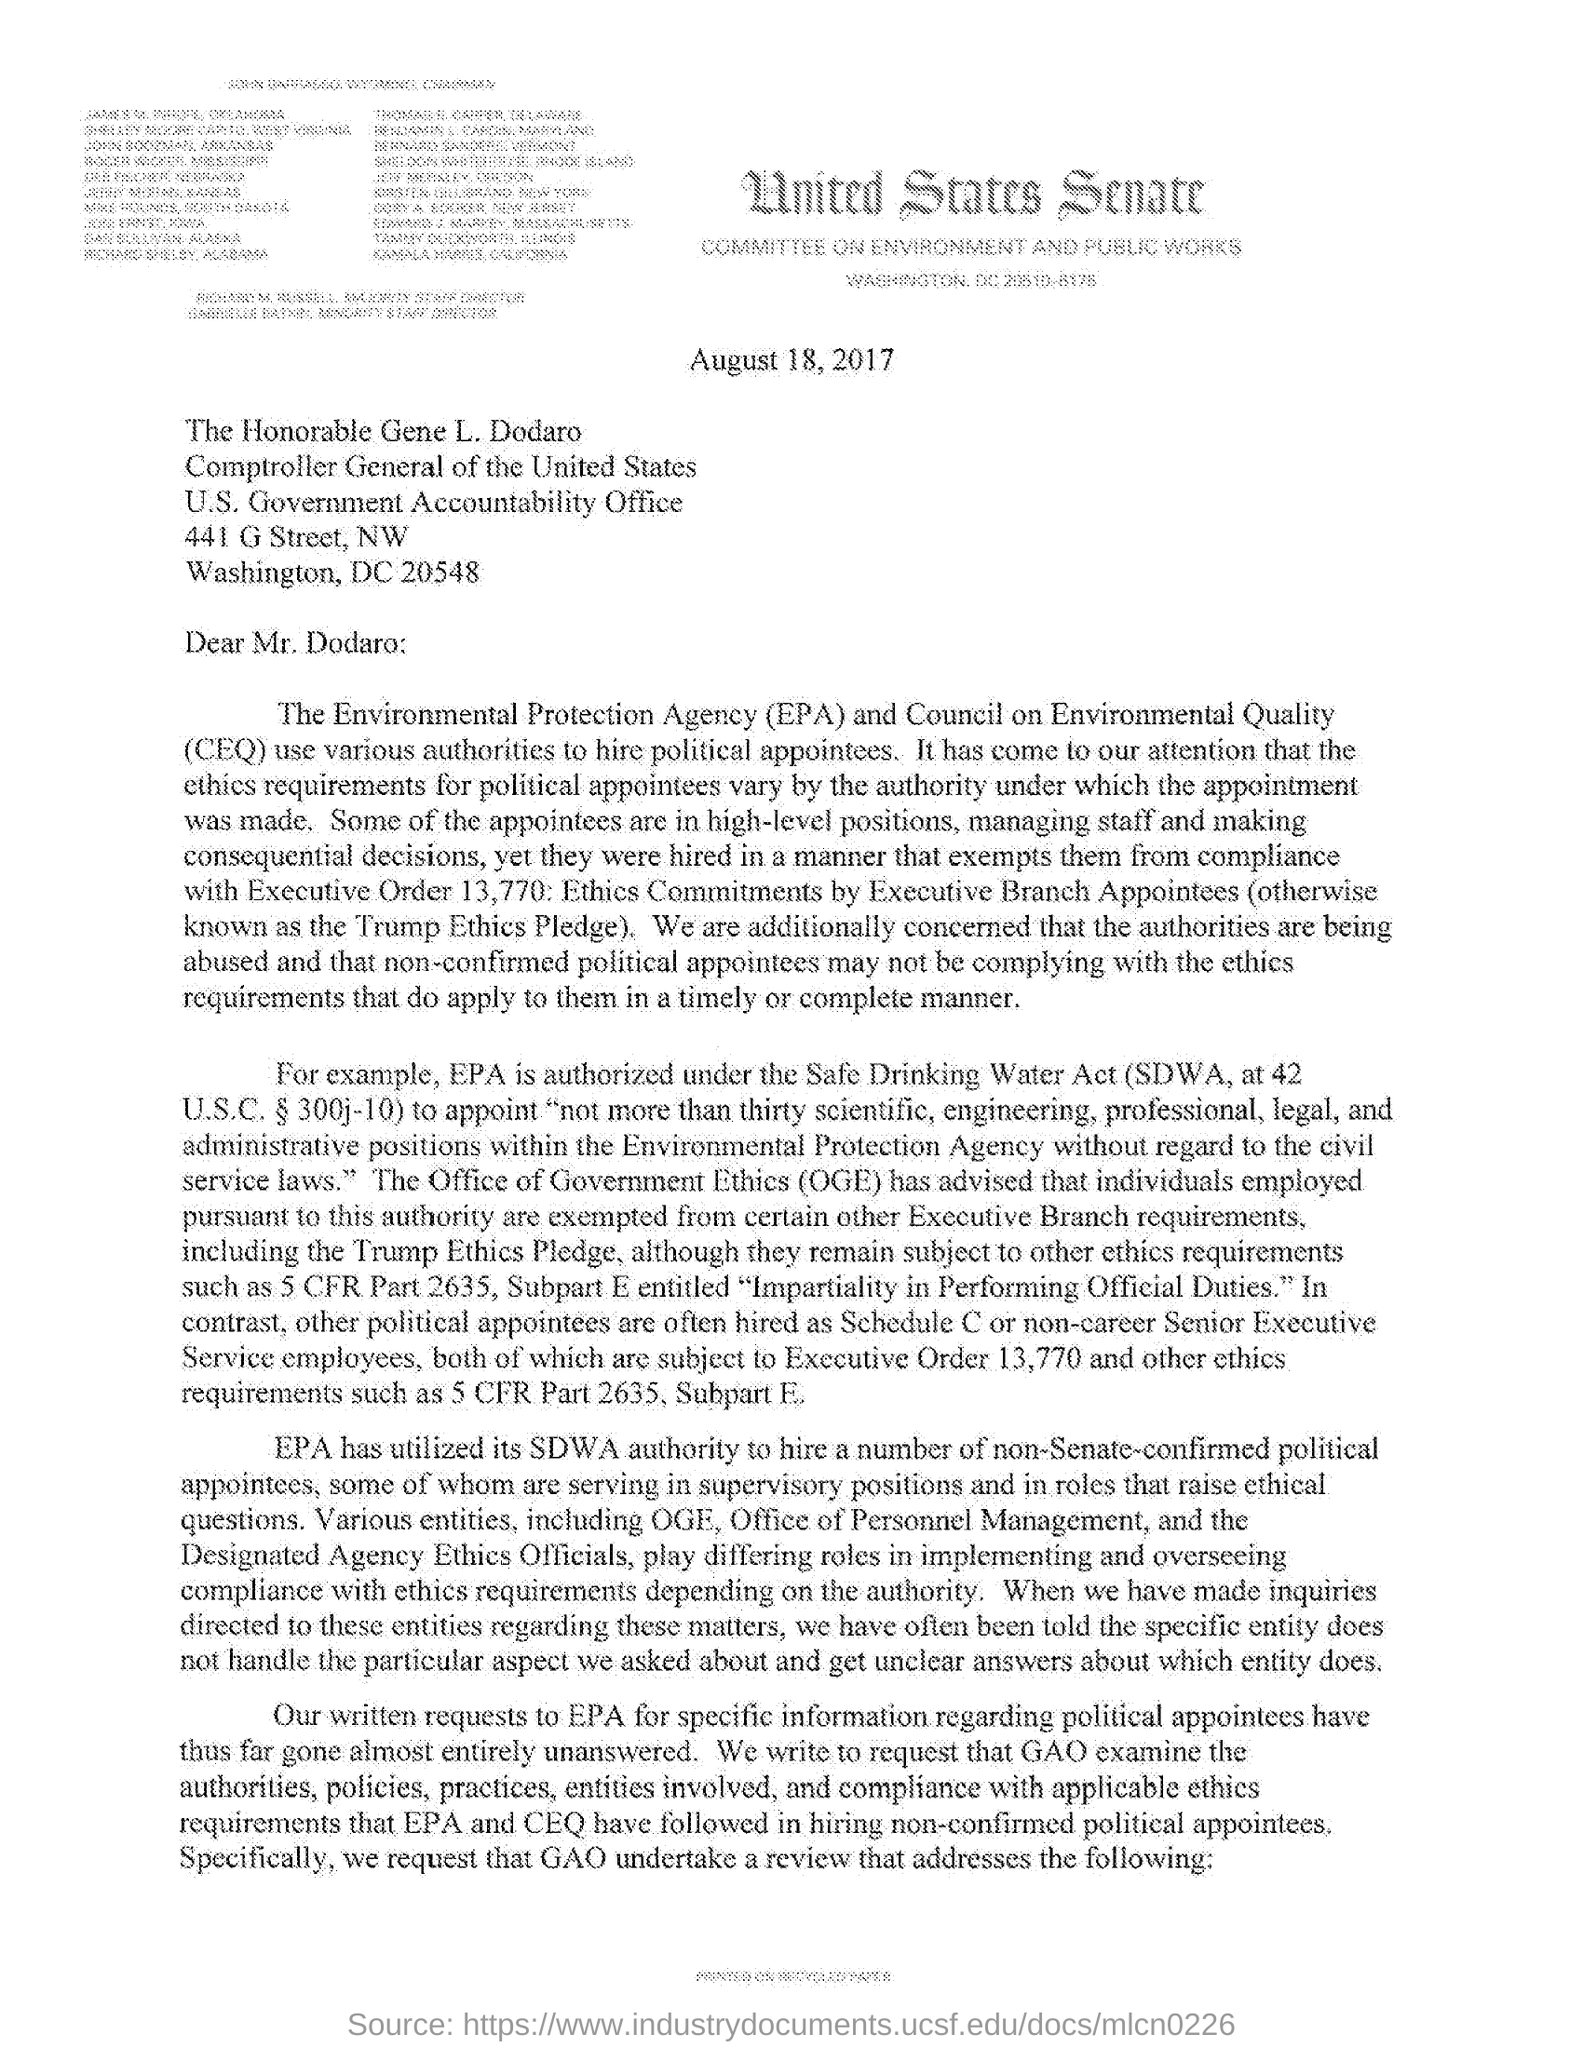Identify some key points in this picture. The addressee of this letter is THE HONORABLE GENE L. DODARO. The acronym "CEQ" stands for "Council on Environmental Quality. The issued date of the letter is August 18, 2017. The Environmental Protection Agency (EPA) uses the Safe Drinking Water Act (SDWA) to hire a number of non-Senate-confirmed political appointees. 